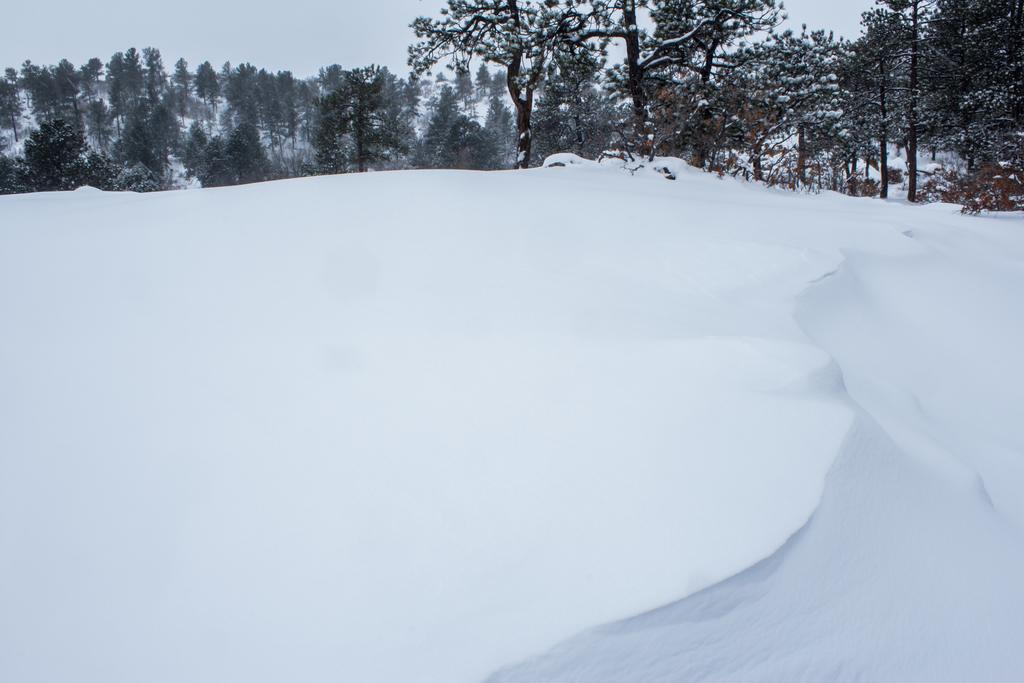What is the main feature in the foreground of the image? There is a snow surface in the foreground of the image. What type of vegetation can be seen in the image? There are trees visible in the image. What can be seen in the background of the image? The background of the image appears to be mountains. What is the chance of finding a vest in the image? There is no mention of a vest in the image, so it cannot be determined if there is a chance of finding one. 